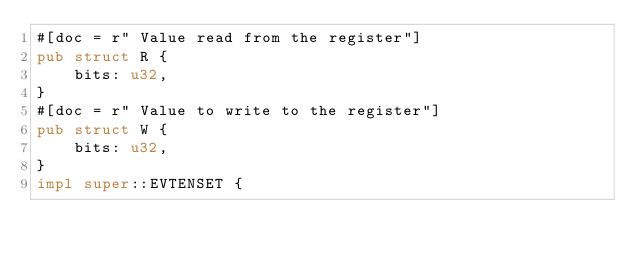Convert code to text. <code><loc_0><loc_0><loc_500><loc_500><_Rust_>#[doc = r" Value read from the register"]
pub struct R {
    bits: u32,
}
#[doc = r" Value to write to the register"]
pub struct W {
    bits: u32,
}
impl super::EVTENSET {</code> 